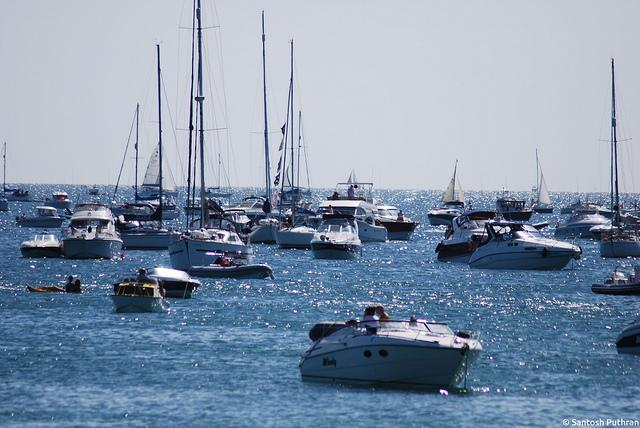Why do some boats have a big pole sticking up from it? for sails 